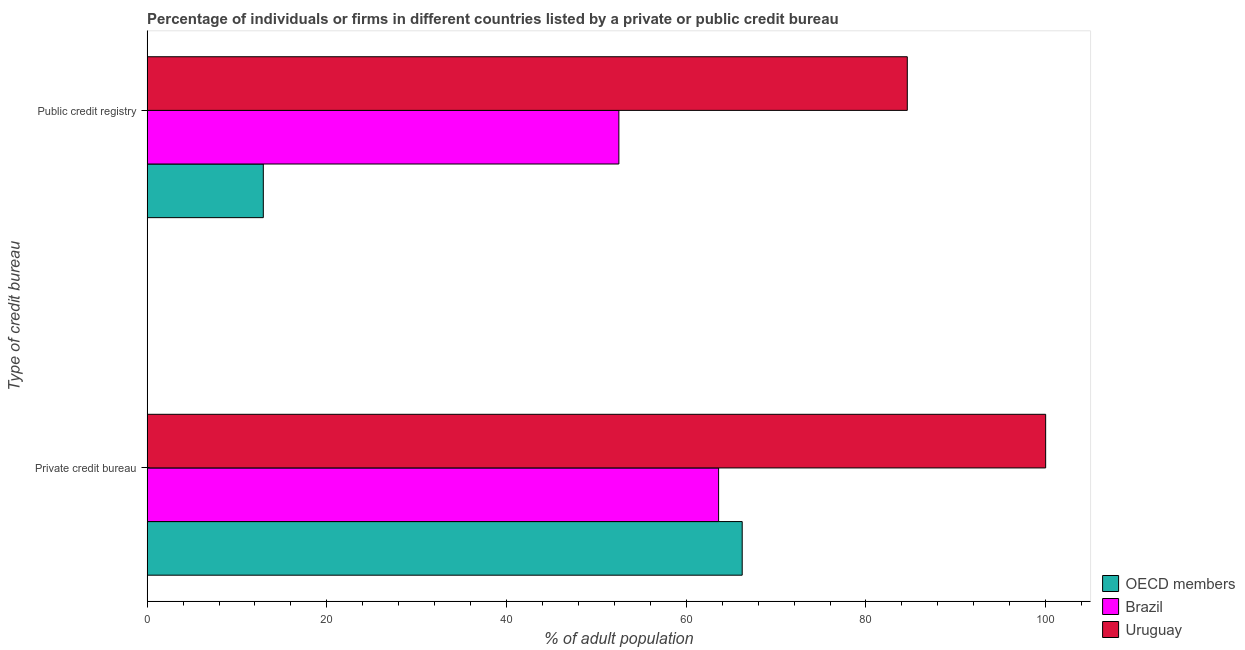How many different coloured bars are there?
Offer a very short reply. 3. How many groups of bars are there?
Offer a terse response. 2. Are the number of bars on each tick of the Y-axis equal?
Offer a very short reply. Yes. How many bars are there on the 1st tick from the top?
Keep it short and to the point. 3. How many bars are there on the 2nd tick from the bottom?
Your answer should be very brief. 3. What is the label of the 2nd group of bars from the top?
Your response must be concise. Private credit bureau. What is the percentage of firms listed by public credit bureau in OECD members?
Offer a terse response. 12.93. Across all countries, what is the minimum percentage of firms listed by private credit bureau?
Provide a succinct answer. 63.6. In which country was the percentage of firms listed by private credit bureau maximum?
Give a very brief answer. Uruguay. What is the total percentage of firms listed by public credit bureau in the graph?
Your response must be concise. 150.03. What is the difference between the percentage of firms listed by private credit bureau in Brazil and that in Uruguay?
Your answer should be compact. -36.4. What is the difference between the percentage of firms listed by private credit bureau in OECD members and the percentage of firms listed by public credit bureau in Brazil?
Make the answer very short. 13.73. What is the average percentage of firms listed by private credit bureau per country?
Provide a short and direct response. 76.61. What is the difference between the percentage of firms listed by private credit bureau and percentage of firms listed by public credit bureau in Uruguay?
Give a very brief answer. 15.4. What is the ratio of the percentage of firms listed by public credit bureau in Brazil to that in Uruguay?
Give a very brief answer. 0.62. Is the percentage of firms listed by private credit bureau in Uruguay less than that in OECD members?
Ensure brevity in your answer.  No. What does the 1st bar from the top in Public credit registry represents?
Make the answer very short. Uruguay. What does the 3rd bar from the bottom in Public credit registry represents?
Ensure brevity in your answer.  Uruguay. Are the values on the major ticks of X-axis written in scientific E-notation?
Make the answer very short. No. Does the graph contain any zero values?
Make the answer very short. No. Does the graph contain grids?
Offer a terse response. No. How many legend labels are there?
Offer a very short reply. 3. What is the title of the graph?
Offer a very short reply. Percentage of individuals or firms in different countries listed by a private or public credit bureau. What is the label or title of the X-axis?
Keep it short and to the point. % of adult population. What is the label or title of the Y-axis?
Ensure brevity in your answer.  Type of credit bureau. What is the % of adult population in OECD members in Private credit bureau?
Offer a very short reply. 66.23. What is the % of adult population in Brazil in Private credit bureau?
Give a very brief answer. 63.6. What is the % of adult population of OECD members in Public credit registry?
Offer a very short reply. 12.93. What is the % of adult population in Brazil in Public credit registry?
Offer a very short reply. 52.5. What is the % of adult population in Uruguay in Public credit registry?
Your answer should be very brief. 84.6. Across all Type of credit bureau, what is the maximum % of adult population in OECD members?
Your answer should be compact. 66.23. Across all Type of credit bureau, what is the maximum % of adult population in Brazil?
Offer a very short reply. 63.6. Across all Type of credit bureau, what is the minimum % of adult population in OECD members?
Your answer should be very brief. 12.93. Across all Type of credit bureau, what is the minimum % of adult population in Brazil?
Offer a very short reply. 52.5. Across all Type of credit bureau, what is the minimum % of adult population of Uruguay?
Your response must be concise. 84.6. What is the total % of adult population of OECD members in the graph?
Keep it short and to the point. 79.15. What is the total % of adult population in Brazil in the graph?
Offer a terse response. 116.1. What is the total % of adult population of Uruguay in the graph?
Offer a terse response. 184.6. What is the difference between the % of adult population of OECD members in Private credit bureau and that in Public credit registry?
Your response must be concise. 53.3. What is the difference between the % of adult population of Uruguay in Private credit bureau and that in Public credit registry?
Provide a succinct answer. 15.4. What is the difference between the % of adult population in OECD members in Private credit bureau and the % of adult population in Brazil in Public credit registry?
Your answer should be compact. 13.73. What is the difference between the % of adult population in OECD members in Private credit bureau and the % of adult population in Uruguay in Public credit registry?
Your response must be concise. -18.37. What is the average % of adult population in OECD members per Type of credit bureau?
Make the answer very short. 39.58. What is the average % of adult population in Brazil per Type of credit bureau?
Make the answer very short. 58.05. What is the average % of adult population in Uruguay per Type of credit bureau?
Give a very brief answer. 92.3. What is the difference between the % of adult population of OECD members and % of adult population of Brazil in Private credit bureau?
Your answer should be compact. 2.63. What is the difference between the % of adult population of OECD members and % of adult population of Uruguay in Private credit bureau?
Make the answer very short. -33.77. What is the difference between the % of adult population of Brazil and % of adult population of Uruguay in Private credit bureau?
Ensure brevity in your answer.  -36.4. What is the difference between the % of adult population in OECD members and % of adult population in Brazil in Public credit registry?
Offer a terse response. -39.57. What is the difference between the % of adult population of OECD members and % of adult population of Uruguay in Public credit registry?
Keep it short and to the point. -71.67. What is the difference between the % of adult population in Brazil and % of adult population in Uruguay in Public credit registry?
Ensure brevity in your answer.  -32.1. What is the ratio of the % of adult population in OECD members in Private credit bureau to that in Public credit registry?
Your response must be concise. 5.12. What is the ratio of the % of adult population in Brazil in Private credit bureau to that in Public credit registry?
Provide a succinct answer. 1.21. What is the ratio of the % of adult population of Uruguay in Private credit bureau to that in Public credit registry?
Make the answer very short. 1.18. What is the difference between the highest and the second highest % of adult population in OECD members?
Your answer should be compact. 53.3. What is the difference between the highest and the lowest % of adult population in OECD members?
Keep it short and to the point. 53.3. What is the difference between the highest and the lowest % of adult population in Uruguay?
Keep it short and to the point. 15.4. 